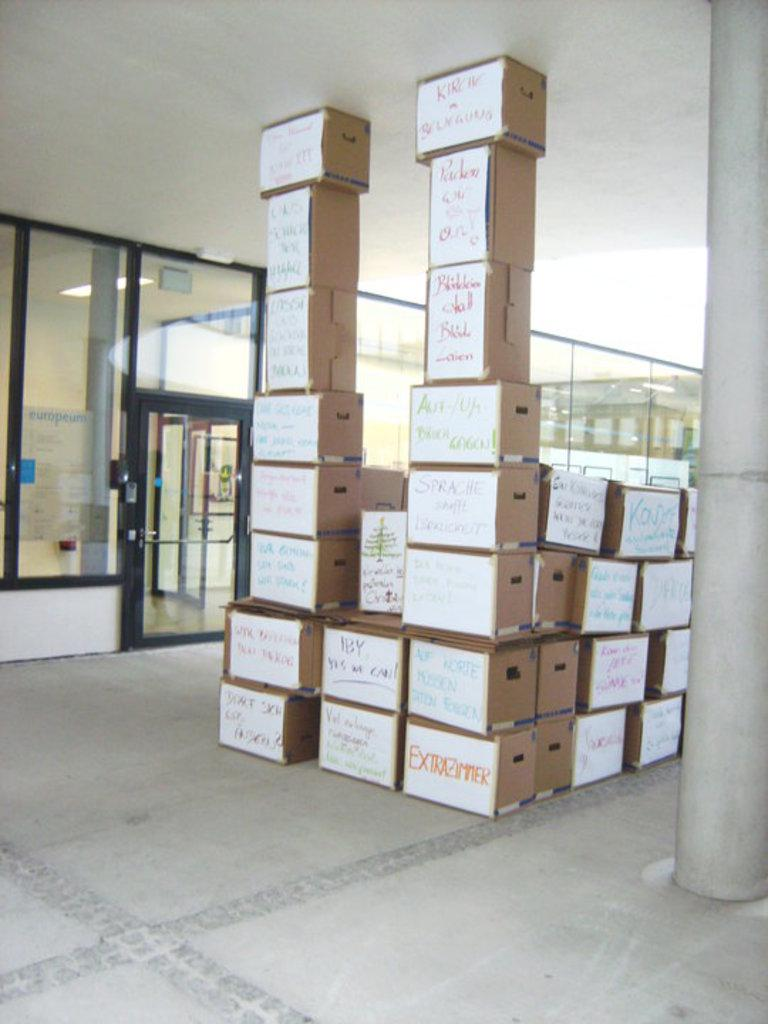<image>
Provide a brief description of the given image. Stacks of cardboard boxes with white hand-written labels on them stand outside a building, including a box labeled Extrazimmer. 